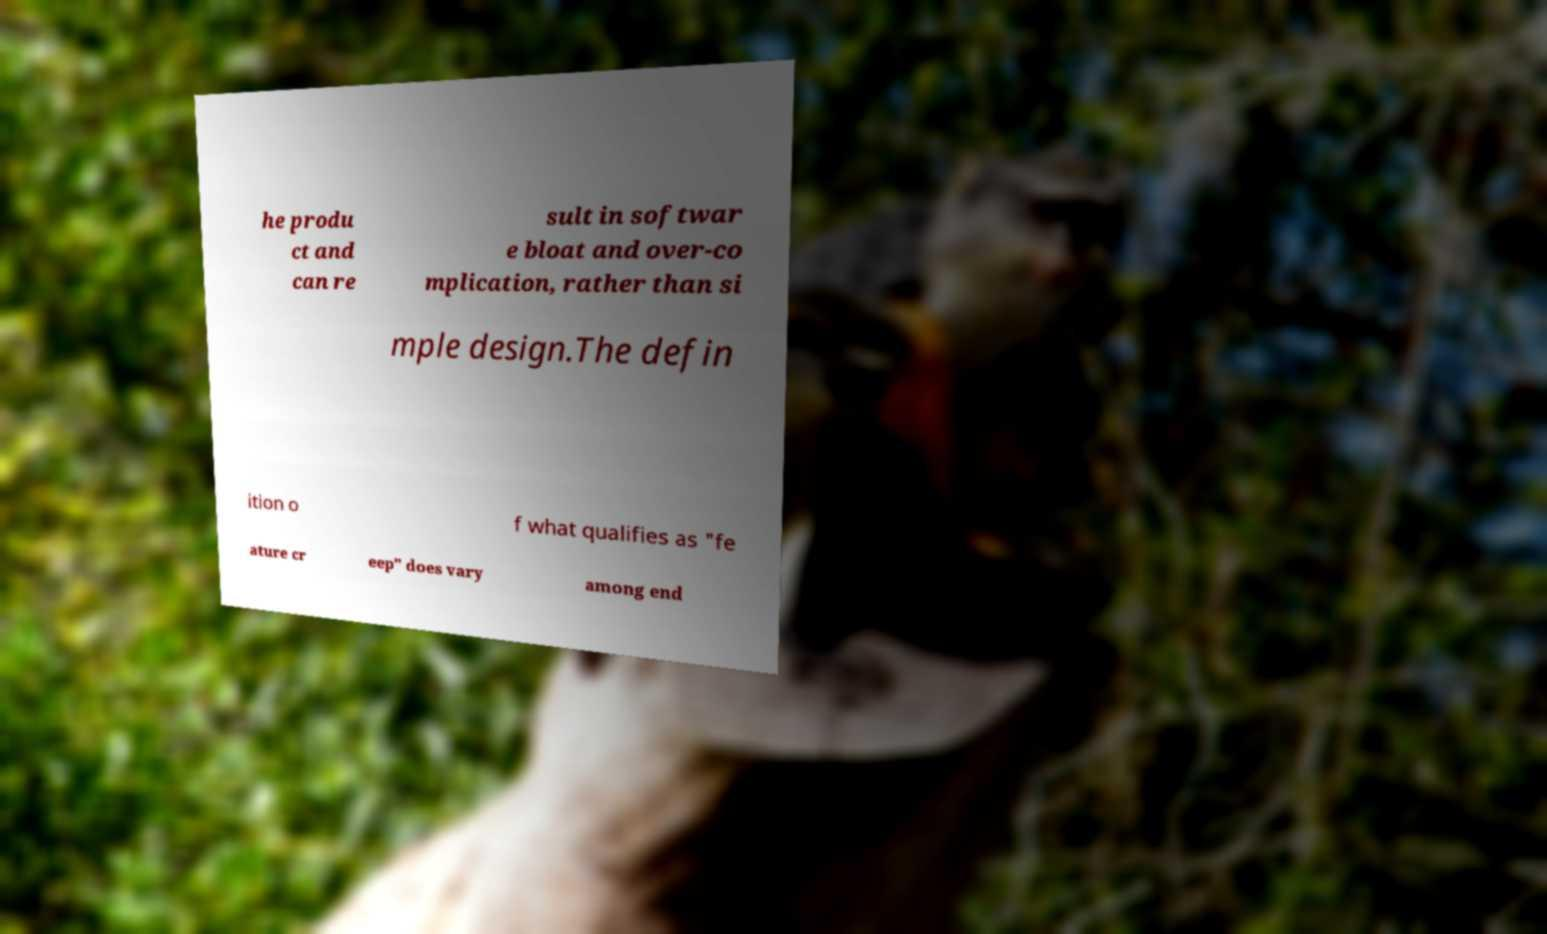Please read and relay the text visible in this image. What does it say? he produ ct and can re sult in softwar e bloat and over-co mplication, rather than si mple design.The defin ition o f what qualifies as "fe ature cr eep" does vary among end 